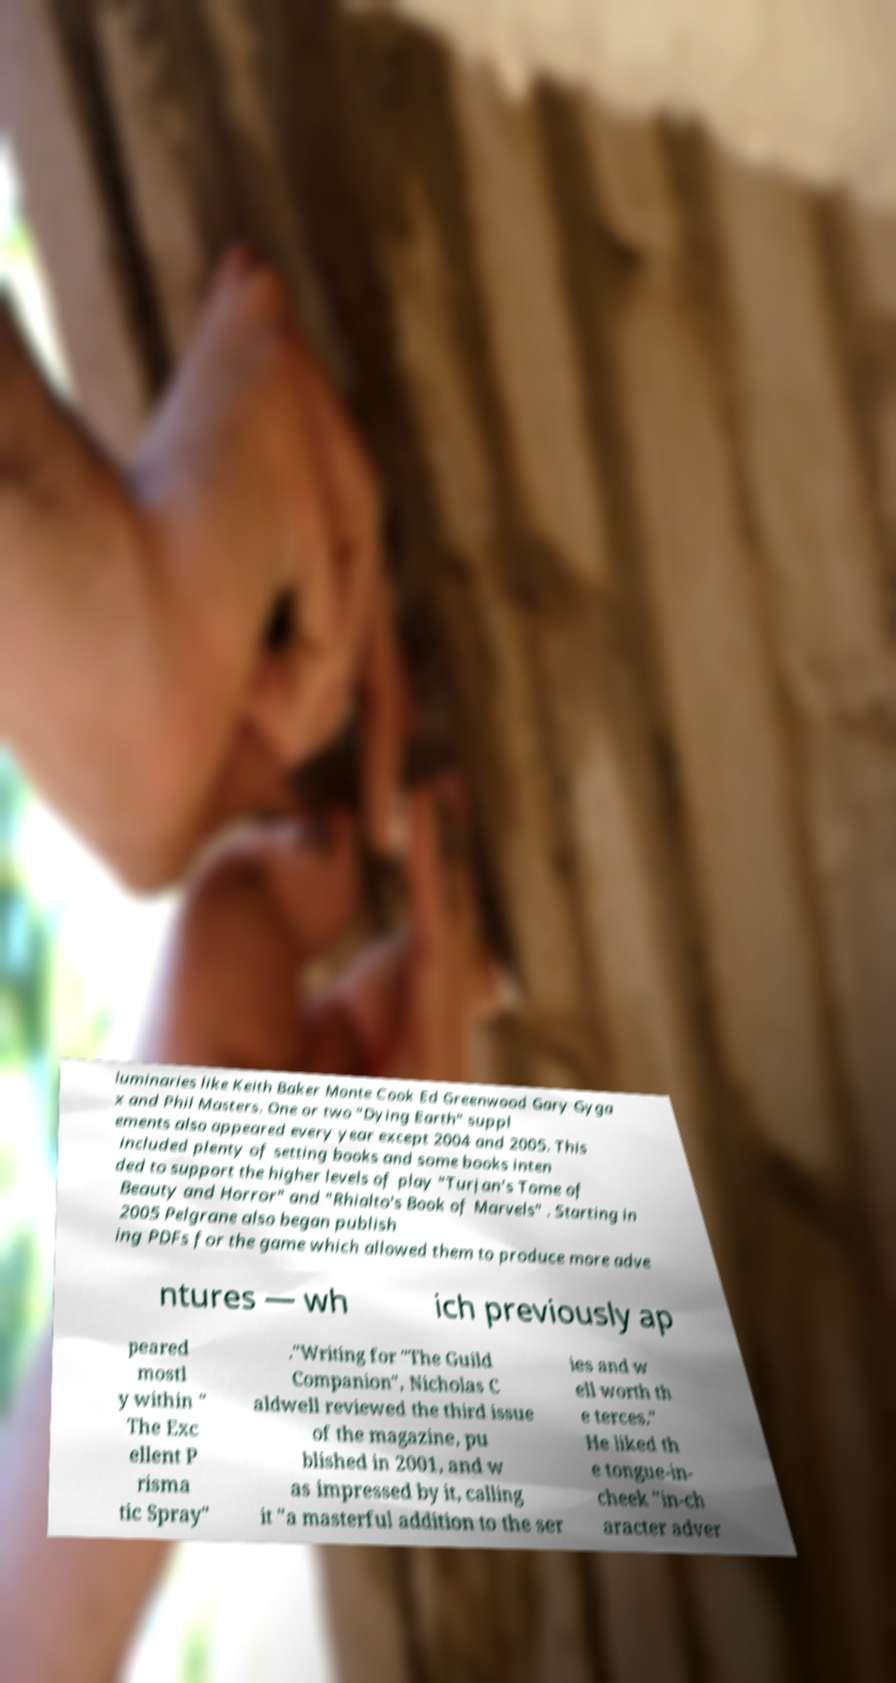I need the written content from this picture converted into text. Can you do that? luminaries like Keith Baker Monte Cook Ed Greenwood Gary Gyga x and Phil Masters. One or two "Dying Earth" suppl ements also appeared every year except 2004 and 2005. This included plenty of setting books and some books inten ded to support the higher levels of play "Turjan's Tome of Beauty and Horror" and "Rhialto's Book of Marvels" . Starting in 2005 Pelgrane also began publish ing PDFs for the game which allowed them to produce more adve ntures — wh ich previously ap peared mostl y within " The Exc ellent P risma tic Spray" ."Writing for "The Guild Companion", Nicholas C aldwell reviewed the third issue of the magazine, pu blished in 2001, and w as impressed by it, calling it "a masterful addition to the ser ies and w ell worth th e terces." He liked th e tongue-in- cheek "in-ch aracter adver 